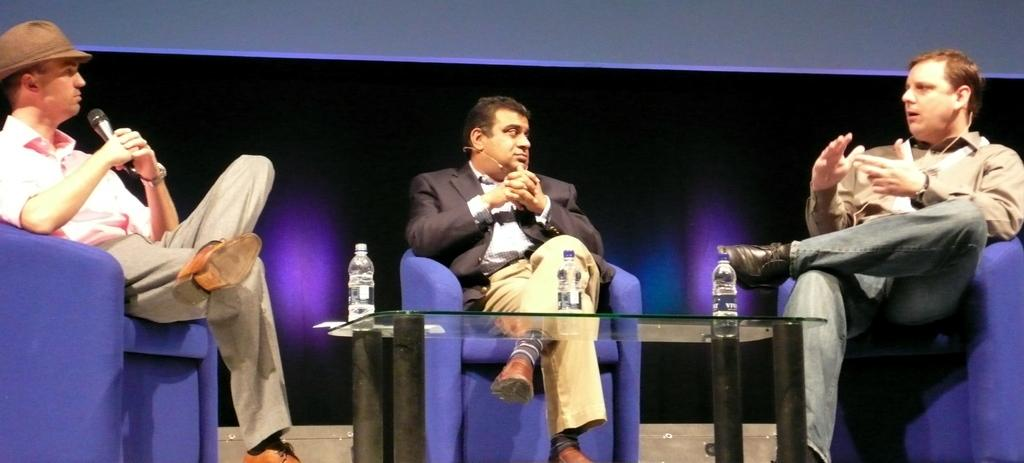What are the people in the image doing? The people in the image are sitting on chairs. What can be seen on the glass object in the image? There are bottles placed on a glass object in the image. What type of owl can be seen making a joke to the people sitting on chairs? There is no owl present in the image, and no one is making a joke to the people sitting on chairs. 